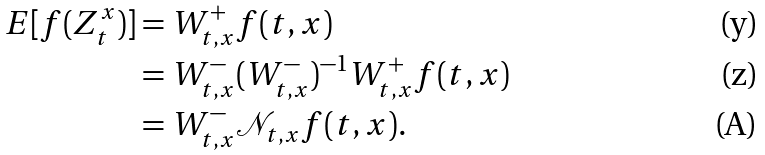<formula> <loc_0><loc_0><loc_500><loc_500>E [ f ( Z ^ { x } _ { t } ) ] & = W ^ { + } _ { t , x } f ( t , x ) \\ & = W ^ { - } _ { t , x } ( W ^ { - } _ { t , x } ) ^ { - 1 } W ^ { + } _ { t , x } f ( t , x ) \\ & = W ^ { - } _ { t , x } \mathcal { N } _ { t , x } f ( t , x ) .</formula> 